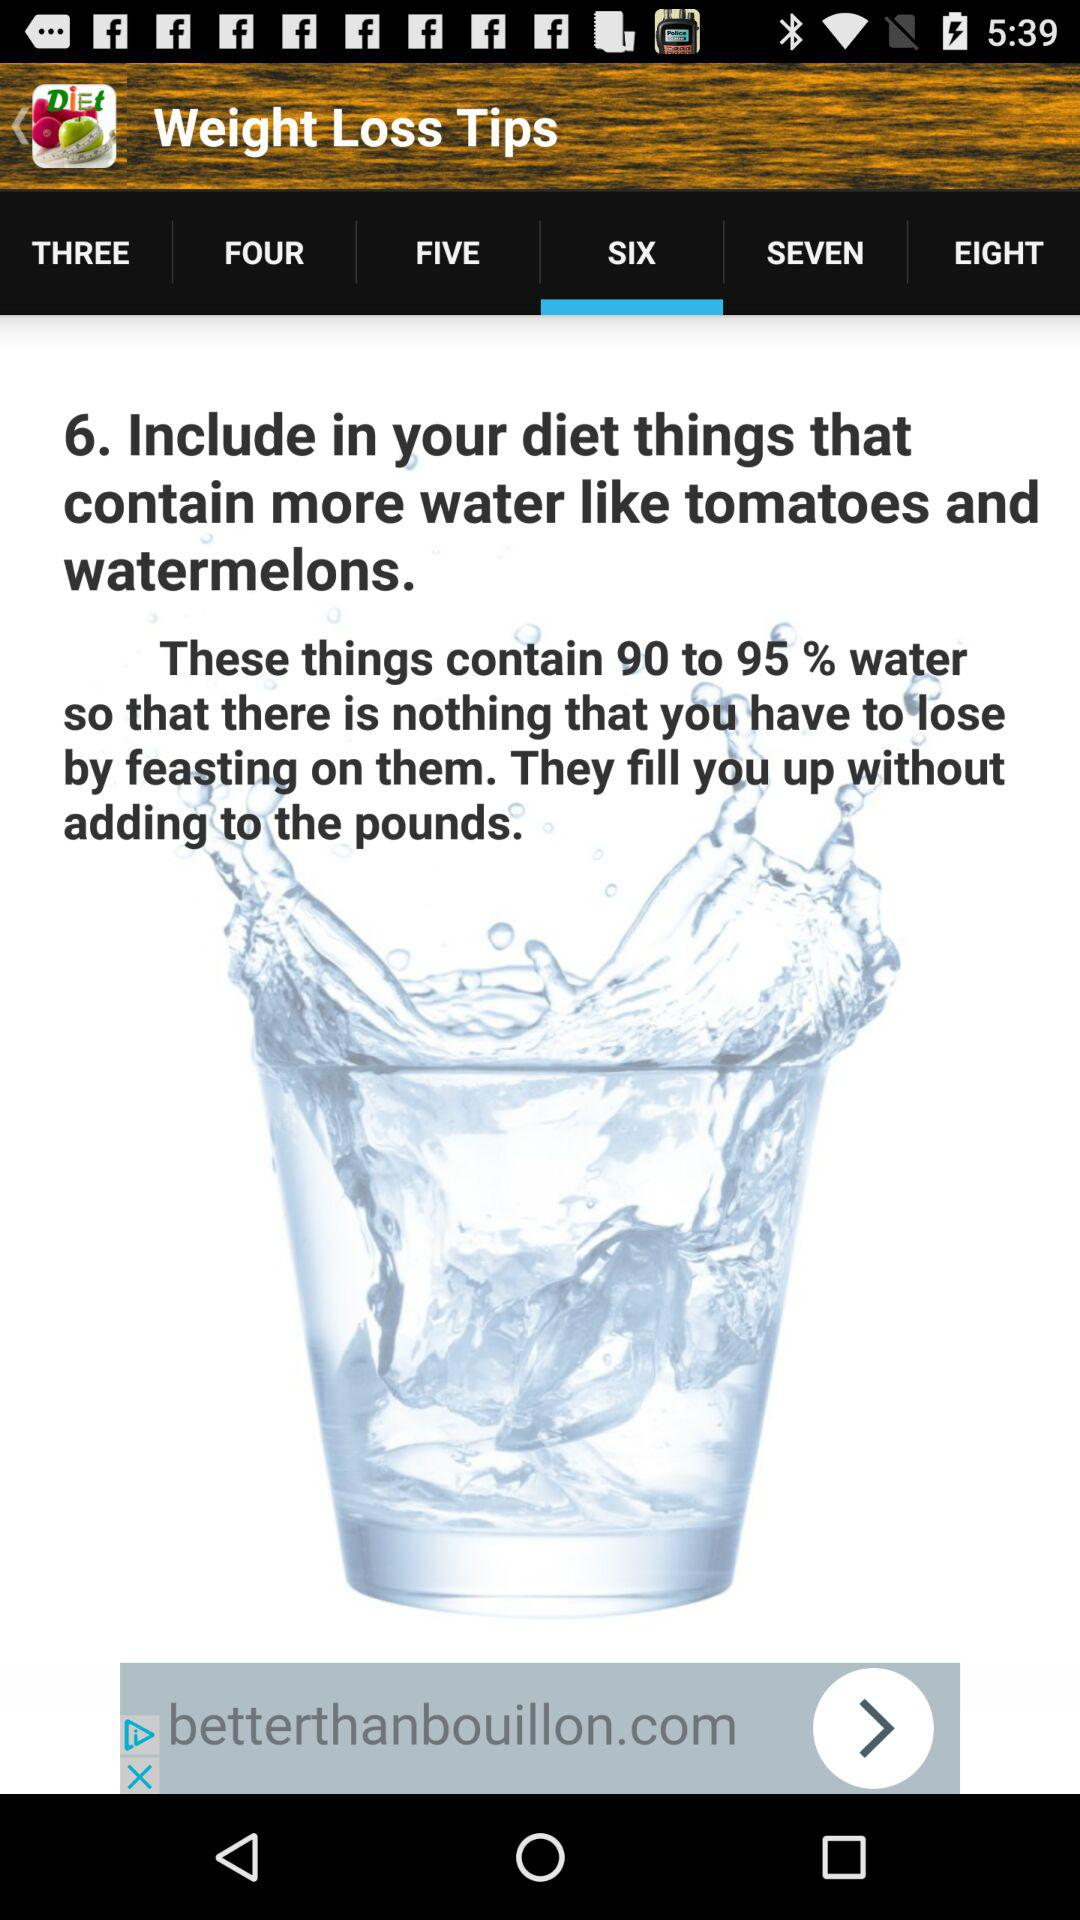How much percentage of water do tomatoes and watermelons contain? Tomatoes and watermelons contain 90 to 95% of water. 